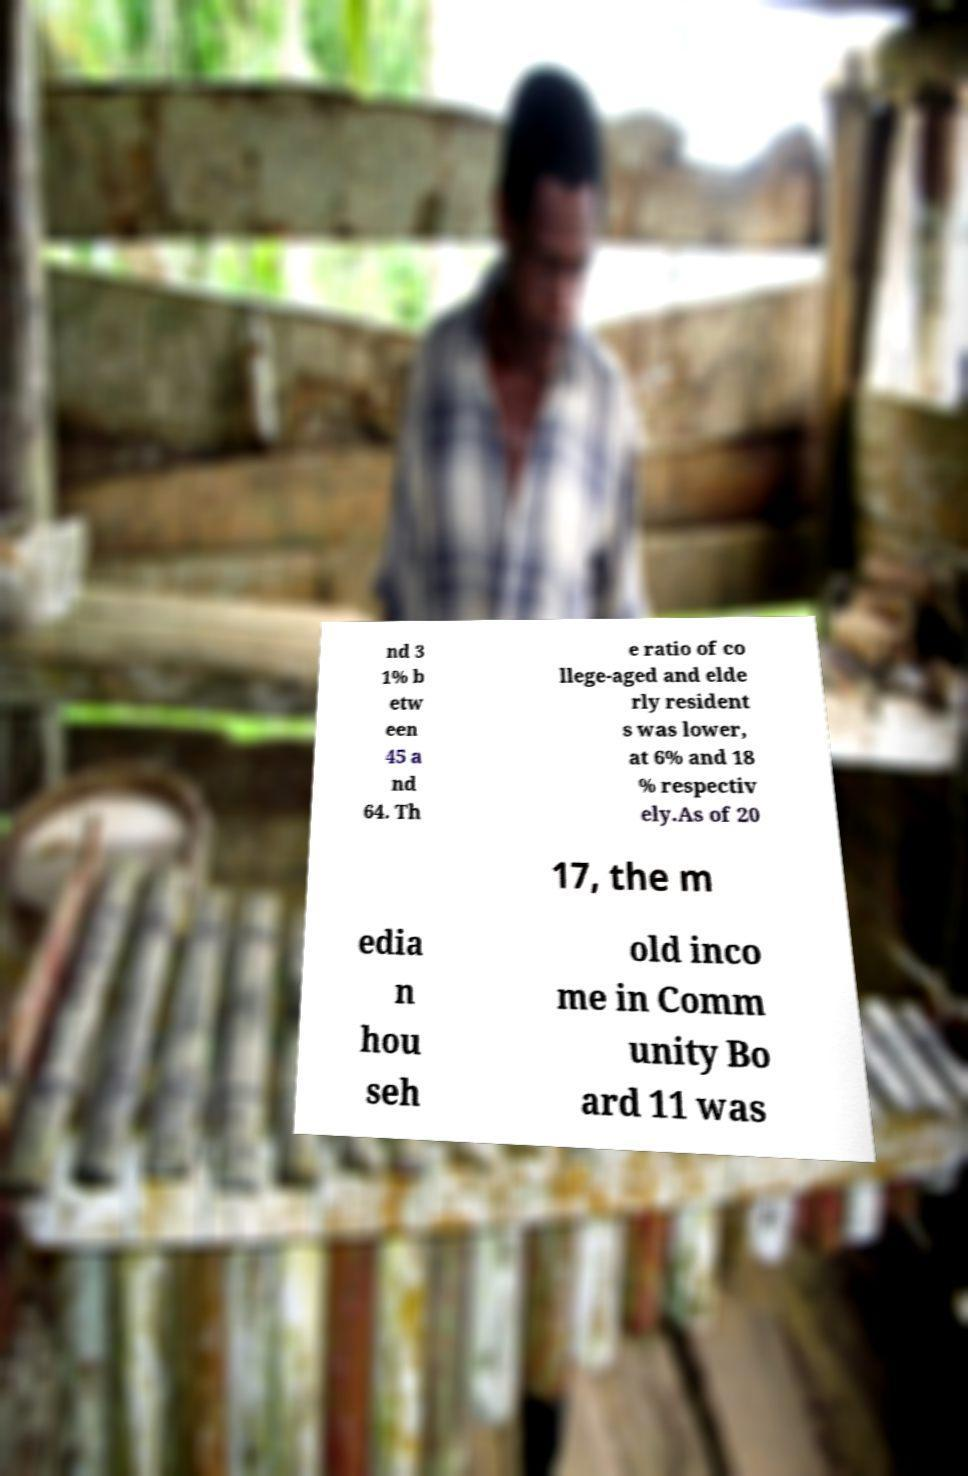Please identify and transcribe the text found in this image. nd 3 1% b etw een 45 a nd 64. Th e ratio of co llege-aged and elde rly resident s was lower, at 6% and 18 % respectiv ely.As of 20 17, the m edia n hou seh old inco me in Comm unity Bo ard 11 was 